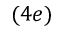<formula> <loc_0><loc_0><loc_500><loc_500>( 4 e )</formula> 